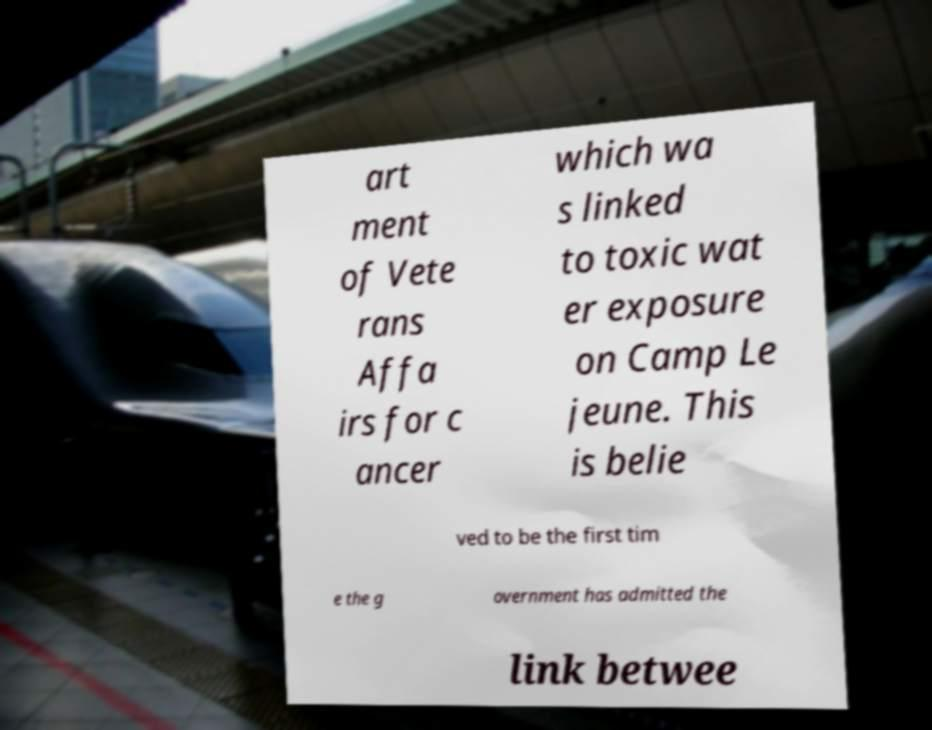What messages or text are displayed in this image? I need them in a readable, typed format. art ment of Vete rans Affa irs for c ancer which wa s linked to toxic wat er exposure on Camp Le jeune. This is belie ved to be the first tim e the g overnment has admitted the link betwee 